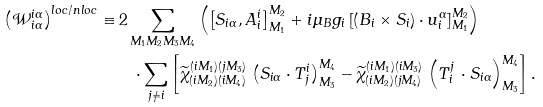<formula> <loc_0><loc_0><loc_500><loc_500>\left ( \mathcal { W } ^ { i \alpha } _ { i \alpha } \right ) ^ { l o c / n l o c } \equiv & \, 2 \sum _ { M _ { 1 } M _ { 2 } M _ { 3 } M _ { 4 } } \left ( \left [ S _ { i \alpha } , A ^ { i } _ { i } \right ] ^ { M _ { 2 } } _ { M _ { 1 } } + i \mu _ { B } g _ { i } \left [ \left ( B _ { i } \times S _ { i } \right ) \cdot u _ { i } ^ { \alpha } \right ] ^ { M _ { 2 } } _ { M _ { 1 } } \right ) \\ & \quad \cdot \sum _ { j \neq i } \left [ \widetilde { \chi } ^ { ( i M _ { 1 } ) ( j M _ { 3 } ) } _ { ( i M _ { 2 } ) ( i M _ { 4 } ) } \, \left ( S _ { i \alpha } \cdot T ^ { i } _ { j } \right ) ^ { M _ { 4 } } _ { M _ { 3 } } - \widetilde { \chi } ^ { ( i M _ { 1 } ) ( i M _ { 3 } ) } _ { ( i M _ { 2 } ) ( j M _ { 4 } ) } \, \left ( T ^ { j } _ { i } \, \cdot S _ { i \alpha } \right ) ^ { M _ { 4 } } _ { M _ { 3 } } \right ] .</formula> 